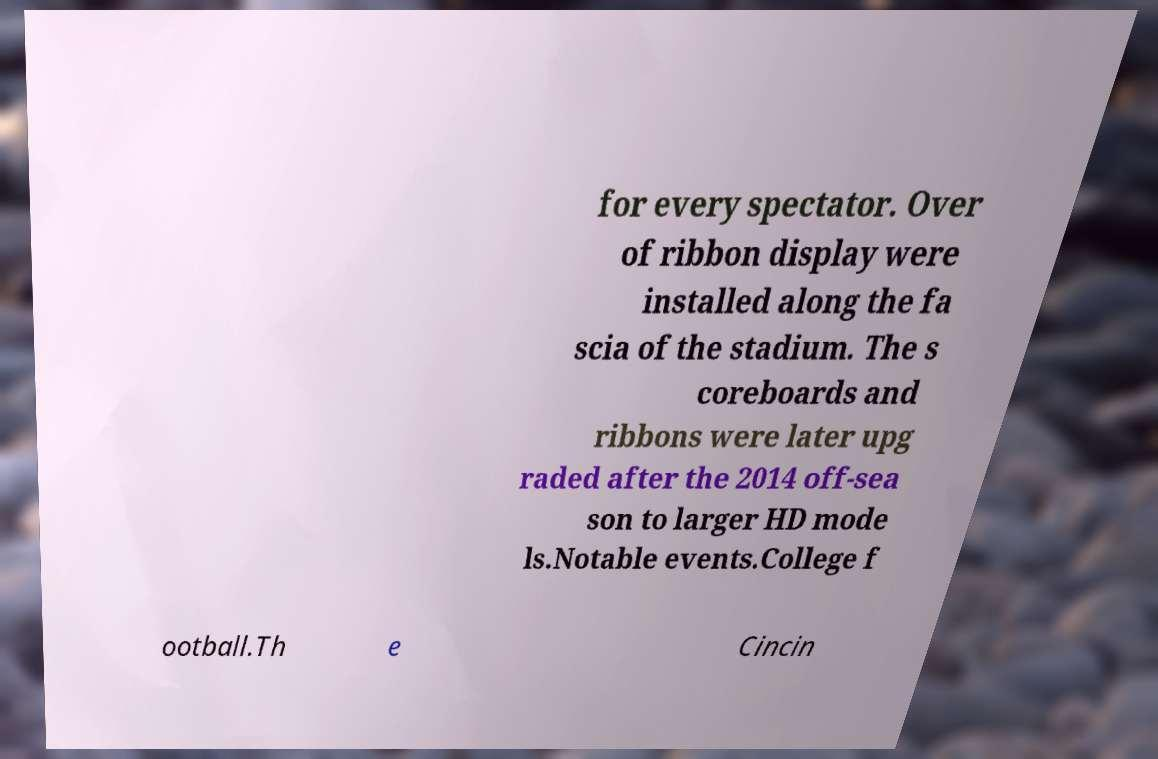I need the written content from this picture converted into text. Can you do that? for every spectator. Over of ribbon display were installed along the fa scia of the stadium. The s coreboards and ribbons were later upg raded after the 2014 off-sea son to larger HD mode ls.Notable events.College f ootball.Th e Cincin 